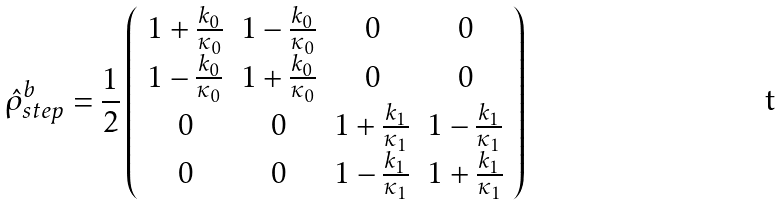Convert formula to latex. <formula><loc_0><loc_0><loc_500><loc_500>\hat { \rho } _ { s t e p } ^ { b } = \frac { 1 } { 2 } \left ( \begin{array} { c c c c } 1 + \frac { k _ { 0 } } { \kappa _ { 0 } } & 1 - \frac { k _ { 0 } } { \kappa _ { 0 } } & 0 & 0 \\ 1 - \frac { k _ { 0 } } { \kappa _ { 0 } } & 1 + \frac { k _ { 0 } } { \kappa _ { 0 } } & 0 & 0 \\ 0 & 0 & 1 + \frac { k _ { 1 } } { \kappa _ { 1 } } & 1 - \frac { k _ { 1 } } { \kappa _ { 1 } } \\ 0 & 0 & 1 - \frac { k _ { 1 } } { \kappa _ { 1 } } & 1 + \frac { k _ { 1 } } { \kappa _ { 1 } } \end{array} \right )</formula> 